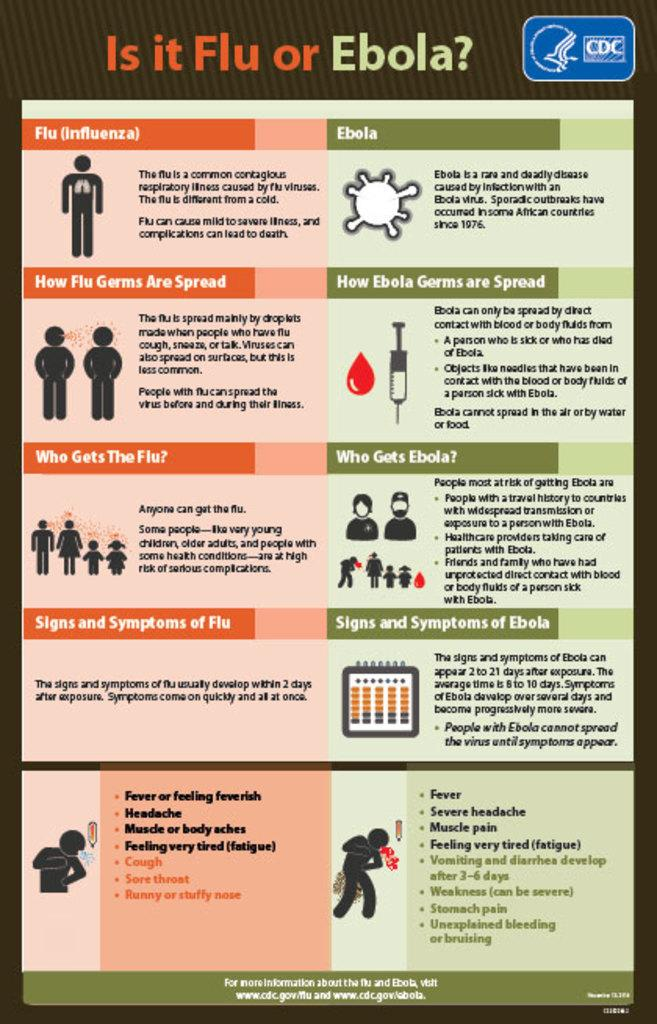Provide a one-sentence caption for the provided image. The poster from the CDC gives guidance on whether someone is suffering from the flu or ebola. 